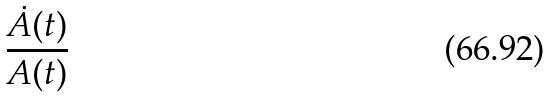<formula> <loc_0><loc_0><loc_500><loc_500>\frac { \dot { A } ( t ) } { A ( t ) }</formula> 